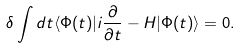Convert formula to latex. <formula><loc_0><loc_0><loc_500><loc_500>\delta \int d t \langle \Phi ( t ) | i \frac { \partial } { \partial t } - H | \Phi ( t ) \rangle = 0 .</formula> 